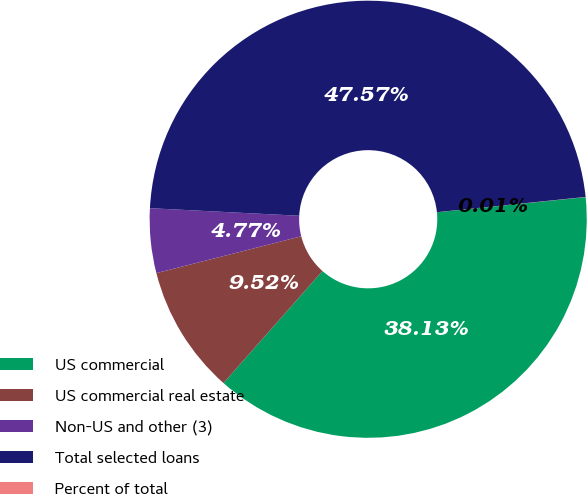Convert chart. <chart><loc_0><loc_0><loc_500><loc_500><pie_chart><fcel>US commercial<fcel>US commercial real estate<fcel>Non-US and other (3)<fcel>Total selected loans<fcel>Percent of total<nl><fcel>38.13%<fcel>9.52%<fcel>4.77%<fcel>47.57%<fcel>0.01%<nl></chart> 